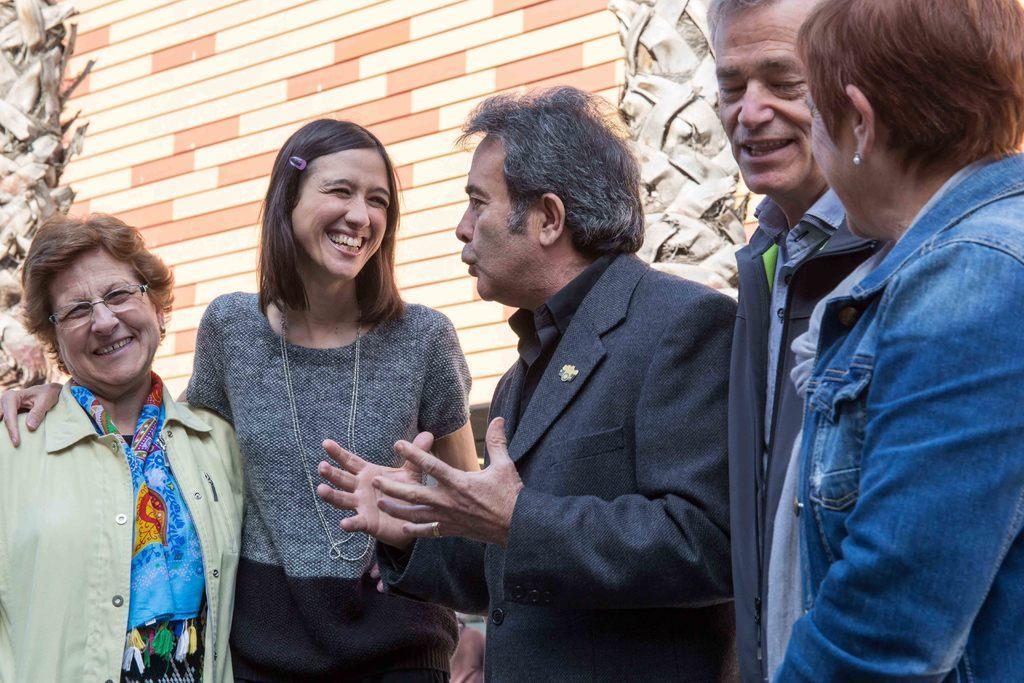Could you give a brief overview of what you see in this image? In the image in the center, we can see a few people are standing and they are smiling, which we can see on their faces. In the background there is a wall and poles. 